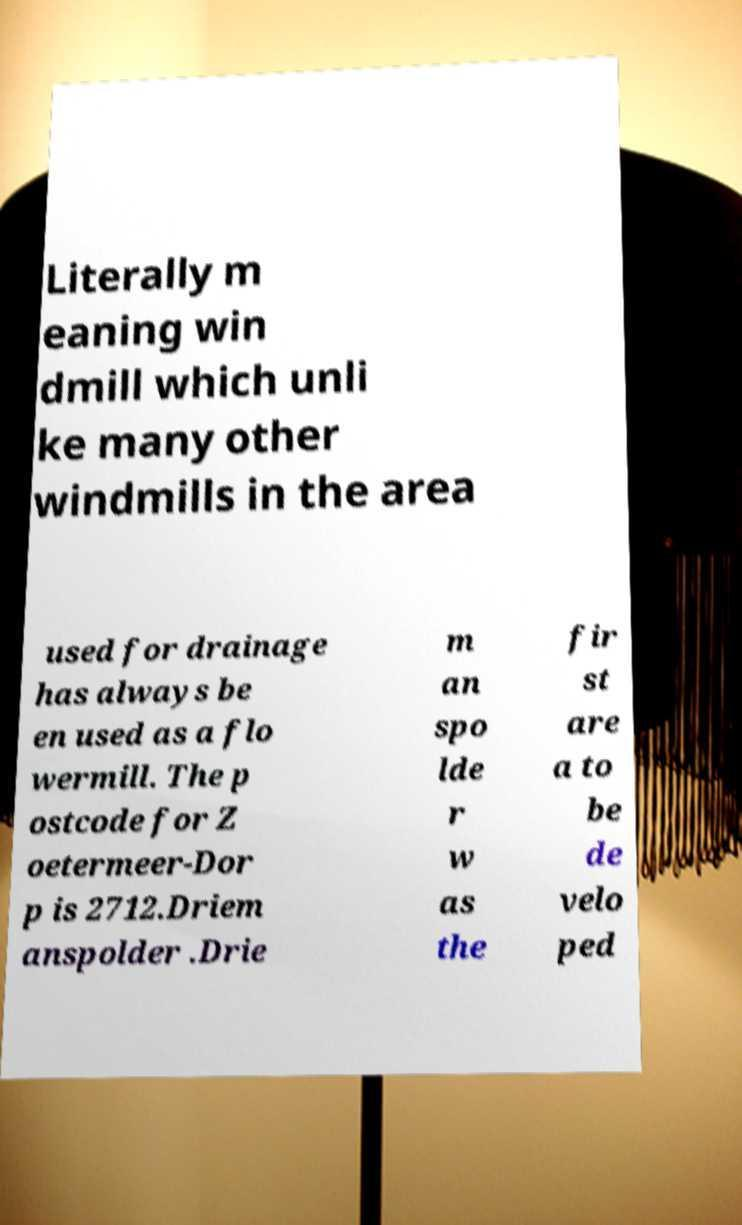Could you assist in decoding the text presented in this image and type it out clearly? Literally m eaning win dmill which unli ke many other windmills in the area used for drainage has always be en used as a flo wermill. The p ostcode for Z oetermeer-Dor p is 2712.Driem anspolder .Drie m an spo lde r w as the fir st are a to be de velo ped 